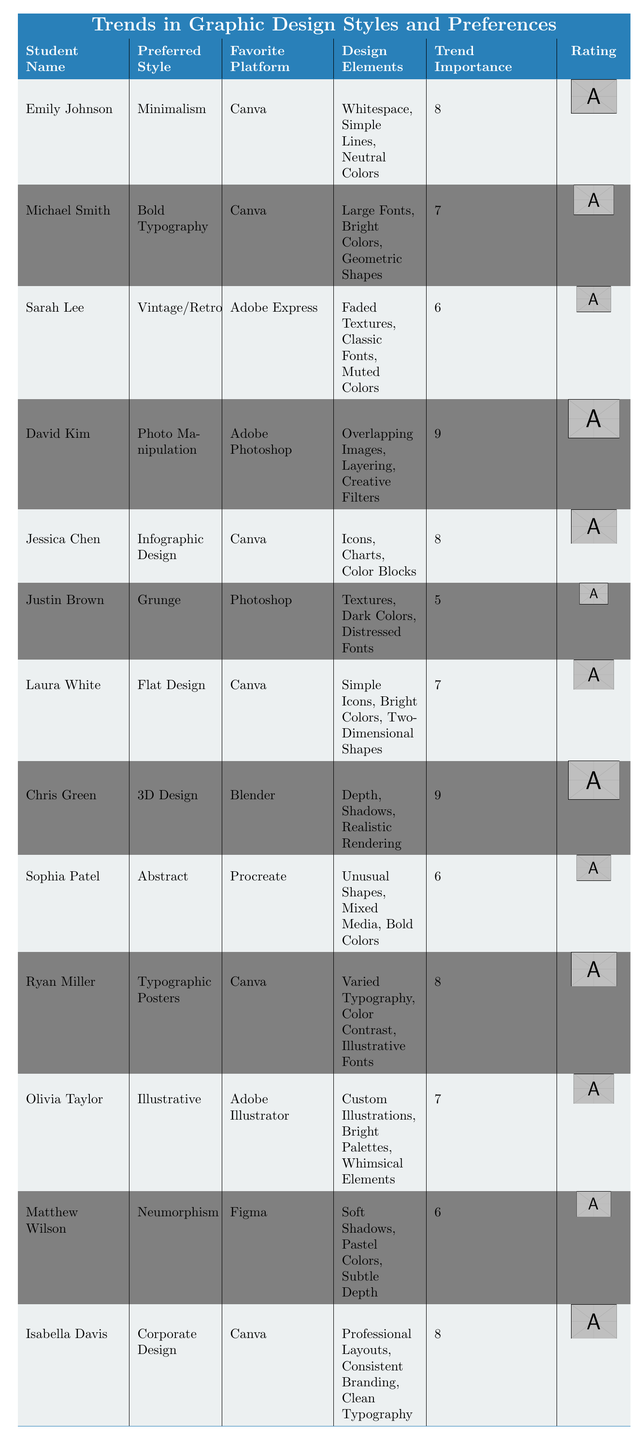What is the preferred style of Emily Johnson? The table lists Emily Johnson and her preferred style is categorized under "Preferred Style," showing her choice as "Minimalism."
Answer: Minimalism Which platform is favored most by the students in the table? By examining the "Favorite Platform" column, Canva appears multiple times; specifically, it is listed as the favorite platform for Emily Johnson, Michael Smith, Jessica Chen, Laura White, Ryan Miller, and Isabella Davis.
Answer: Canva What design elements does David Kim use in his design? Under the "Design Elements" column for David Kim, the listed elements include "Overlapping Images," "Layering," and "Creative Filters."
Answer: Overlapping Images, Layering, Creative Filters How many students prefer 3D Design? Looking at the table, there is only one entry under "Preferred Style" for 3D Design, which is Chris Green.
Answer: 1 What is the average trend importance rating of students who prefer flat design and corporate design? For Flat Design (Laura White), the trend importance is 7, and for Corporate Design (Isabella Davis), it is also 8. Adding these gives 7 + 8 = 15, and dividing by 2 gives an average of 15 / 2 = 7.5.
Answer: 7.5 Is the trend importance rating of typographic posters higher than that of illustrative design? The table shows a trend importance of 8 for Typographic Posters (Ryan Miller) and 7 for Illustrative Design (Olivia Taylor). Therefore, it is true that Typographic Posters has a higher rating.
Answer: Yes Which design style has the highest trend importance rating? By examining the table, both "Photo Manipulation" by David Kim and "3D Design" by Chris Green are tied with the highest trend importance rating of 9.
Answer: Photo Manipulation and 3D Design How many students use Canva as their favorite platform and have a trend importance rating of 8 or above? The students using Canva with a trend importance of 8 or above include Emily Johnson, Jessica Chen, Ryan Miller, and Isabella Davis. This totals to four students.
Answer: 4 What is the difference in trend importance between the styles of Grunge and Corporate Design? The trend importance for Grunge (Justin Brown) is 5, while for Corporate Design (Isabella Davis) it is 8. The difference is calculated as 8 - 5 = 3.
Answer: 3 Which design elements are common among students preferring styles with a trend importance of 8? Looking at the students with a trend importance of 8: Emily Johnson (Minimalism), Jessica Chen (Infographic Design), Ryan Miller (Typographic Posters), and Isabella Davis (Corporate Design) - examining their design elements reveals that neutrality, icons, varied typography, and professionalism are diverse but not common. No specific design element is repeated among them.
Answer: None 